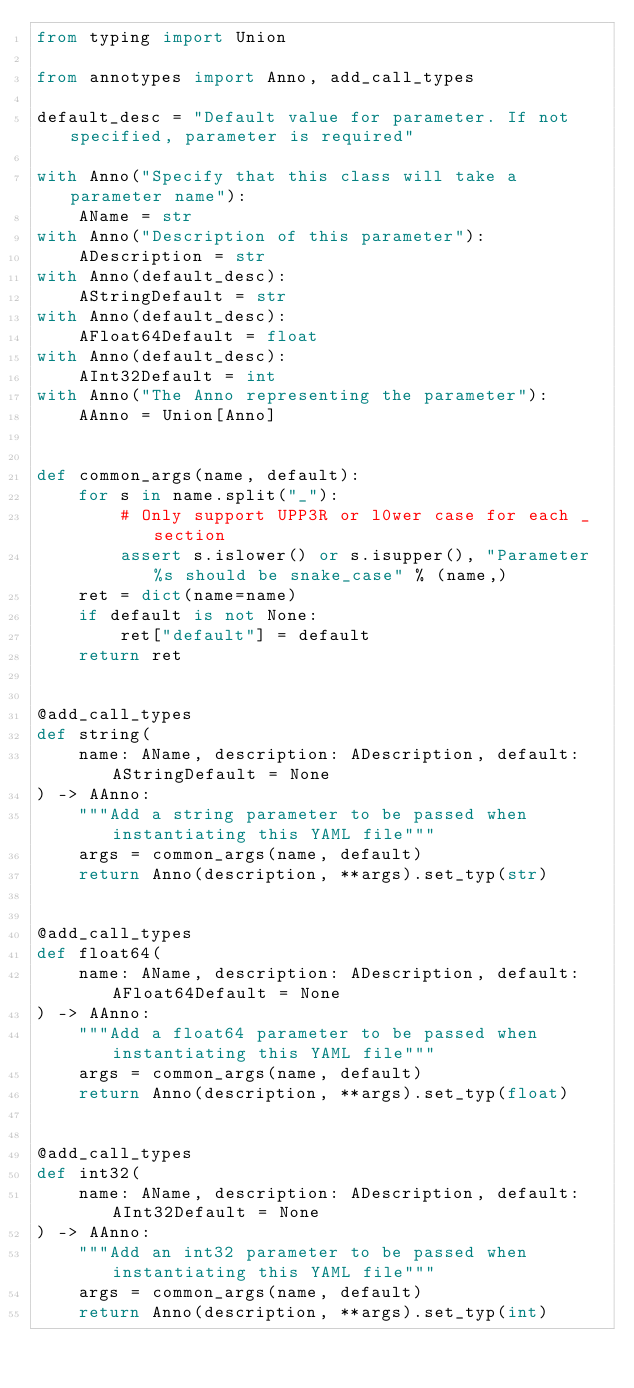<code> <loc_0><loc_0><loc_500><loc_500><_Python_>from typing import Union

from annotypes import Anno, add_call_types

default_desc = "Default value for parameter. If not specified, parameter is required"

with Anno("Specify that this class will take a parameter name"):
    AName = str
with Anno("Description of this parameter"):
    ADescription = str
with Anno(default_desc):
    AStringDefault = str
with Anno(default_desc):
    AFloat64Default = float
with Anno(default_desc):
    AInt32Default = int
with Anno("The Anno representing the parameter"):
    AAnno = Union[Anno]


def common_args(name, default):
    for s in name.split("_"):
        # Only support UPP3R or l0wer case for each _ section
        assert s.islower() or s.isupper(), "Parameter %s should be snake_case" % (name,)
    ret = dict(name=name)
    if default is not None:
        ret["default"] = default
    return ret


@add_call_types
def string(
    name: AName, description: ADescription, default: AStringDefault = None
) -> AAnno:
    """Add a string parameter to be passed when instantiating this YAML file"""
    args = common_args(name, default)
    return Anno(description, **args).set_typ(str)


@add_call_types
def float64(
    name: AName, description: ADescription, default: AFloat64Default = None
) -> AAnno:
    """Add a float64 parameter to be passed when instantiating this YAML file"""
    args = common_args(name, default)
    return Anno(description, **args).set_typ(float)


@add_call_types
def int32(
    name: AName, description: ADescription, default: AInt32Default = None
) -> AAnno:
    """Add an int32 parameter to be passed when instantiating this YAML file"""
    args = common_args(name, default)
    return Anno(description, **args).set_typ(int)
</code> 